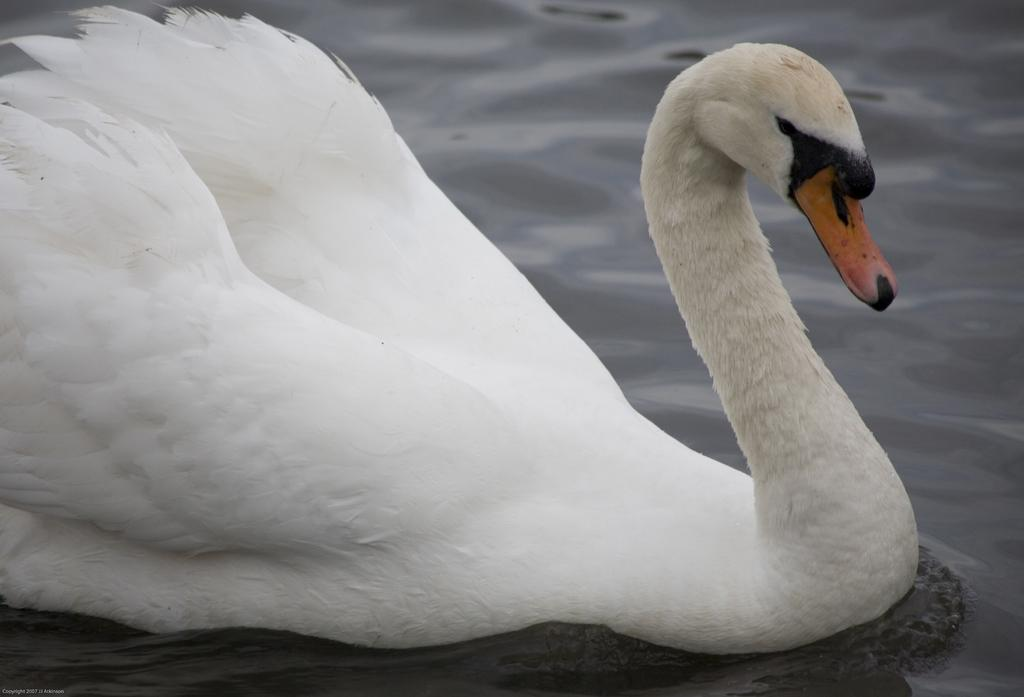What is the main subject of the image? There is a swan in the center of the image. What color is the swan? The swan is white in color. What can be seen in the background of the image? There is water visible in the background of the image. How many babies are sitting on the swan's back in the image? There are no babies present in the image; it features a swan in the water. What type of invention is being used by the crow in the image? There is no crow or invention present in the image; it features a swan in the water. 